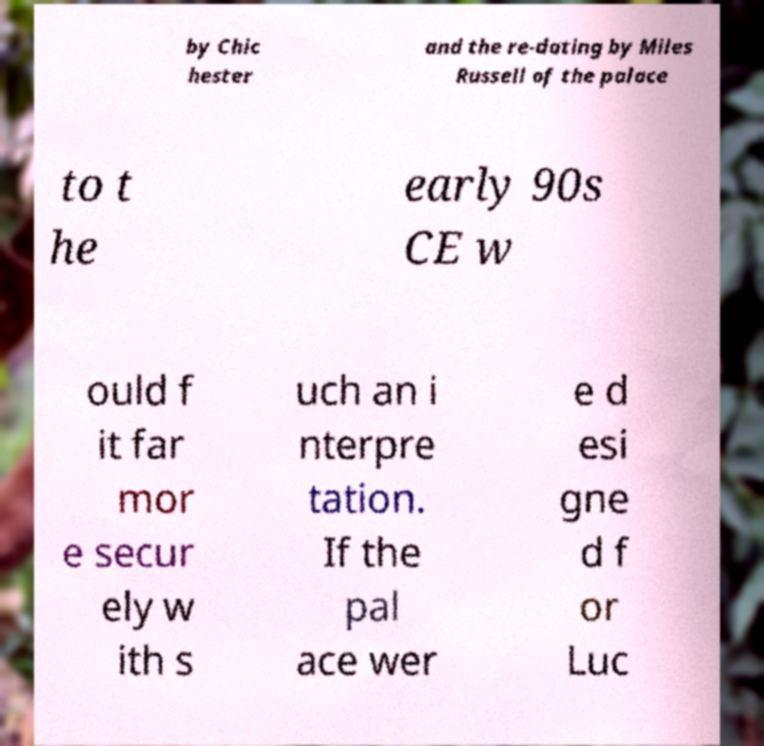What messages or text are displayed in this image? I need them in a readable, typed format. by Chic hester and the re-dating by Miles Russell of the palace to t he early 90s CE w ould f it far mor e secur ely w ith s uch an i nterpre tation. If the pal ace wer e d esi gne d f or Luc 